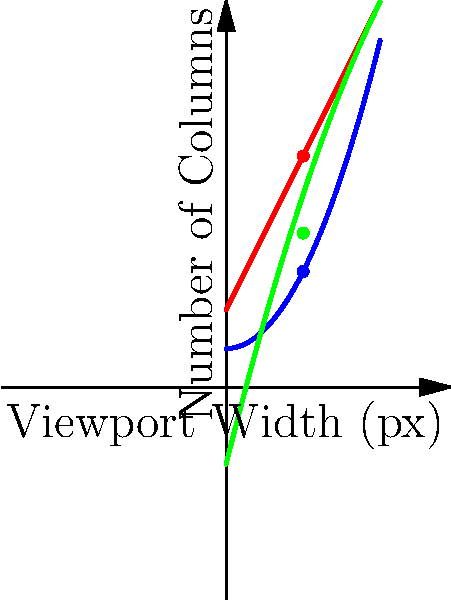A responsive image gallery is designed using CSS Grid with different column configurations for desktop, tablet, and mobile devices. The graph shows the number of columns in the gallery based on the viewport width. At a viewport width of 800px, how many total columns are there across all three device types combined? To solve this problem, we need to follow these steps:

1. Identify the viewport width in question: 800px
2. On the graph, 800px corresponds to x = 2 (assuming the x-axis represents viewport width in hundreds of pixels)
3. Find the number of columns for each device type at x = 2:
   a. Desktop (blue line): $f(2) = 0.5 * 2^2 + 1 = 3$ columns
   b. Tablet (red line): $g(2) = 2 * 2 + 2 = 6$ columns
   c. Mobile (green line): $h(2) = -0.25 * 2^2 + 4 * 2 - 2 = 4$ columns
4. Sum up the columns for all device types:
   $3 + 6 + 4 = 13$ columns in total

Therefore, at a viewport width of 800px, there are 13 columns in total across all three device types.
Answer: 13 columns 